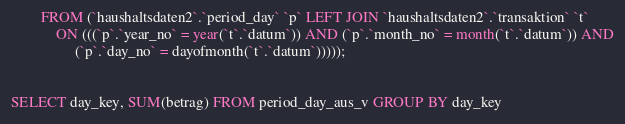<code> <loc_0><loc_0><loc_500><loc_500><_SQL_>        FROM (`haushaltsdaten2`.`period_day` `p` LEFT JOIN `haushaltsdaten2`.`transaktion` `t`
            ON (((`p`.`year_no` = year(`t`.`datum`)) AND (`p`.`month_no` = month(`t`.`datum`)) AND
                 (`p`.`day_no` = dayofmonth(`t`.`datum`)))));
				 

SELECT day_key, SUM(betrag) FROM period_day_aus_v GROUP BY day_key</code> 